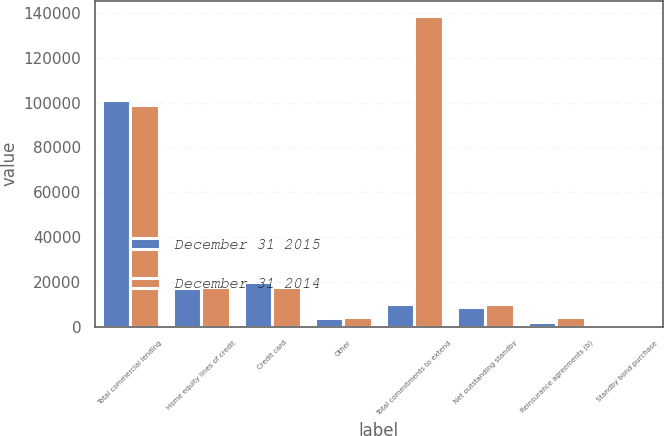Convert chart to OTSL. <chart><loc_0><loc_0><loc_500><loc_500><stacked_bar_chart><ecel><fcel>Total commercial lending<fcel>Home equity lines of credit<fcel>Credit card<fcel>Other<fcel>Total commitments to extend<fcel>Net outstanding standby<fcel>Reinsurance agreements (b)<fcel>Standby bond purchase<nl><fcel>December 31 2015<fcel>101252<fcel>17268<fcel>19937<fcel>4032<fcel>9991<fcel>8765<fcel>2010<fcel>911<nl><fcel>December 31 2014<fcel>98742<fcel>17839<fcel>17833<fcel>4178<fcel>138592<fcel>9991<fcel>4297<fcel>1095<nl></chart> 